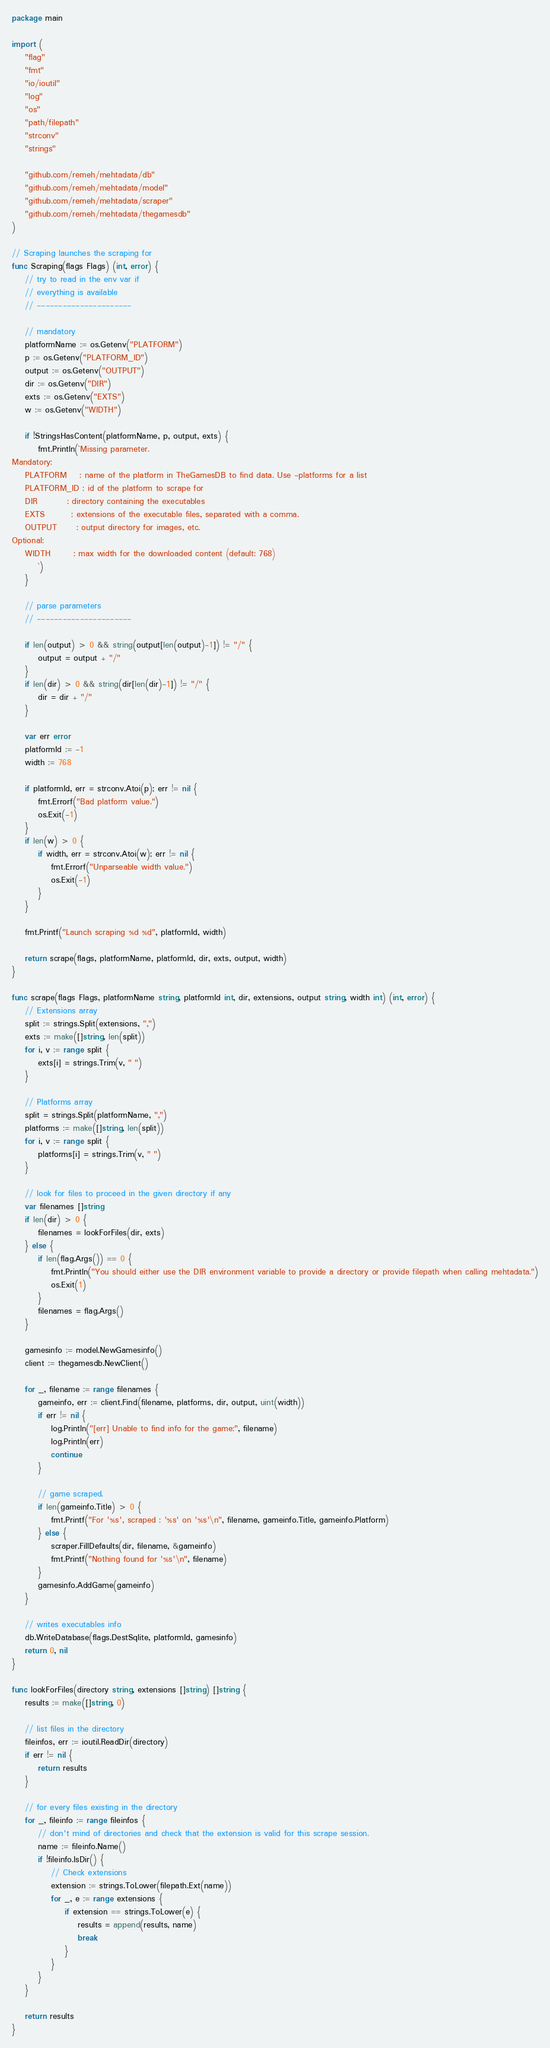Convert code to text. <code><loc_0><loc_0><loc_500><loc_500><_Go_>package main

import (
	"flag"
	"fmt"
	"io/ioutil"
	"log"
	"os"
	"path/filepath"
	"strconv"
	"strings"

	"github.com/remeh/mehtadata/db"
	"github.com/remeh/mehtadata/model"
	"github.com/remeh/mehtadata/scraper"
	"github.com/remeh/mehtadata/thegamesdb"
)

// Scraping launches the scraping for
func Scraping(flags Flags) (int, error) {
	// try to read in the env var if
	// everything is available
	// ----------------------

	// mandatory
	platformName := os.Getenv("PLATFORM")
	p := os.Getenv("PLATFORM_ID")
	output := os.Getenv("OUTPUT")
	dir := os.Getenv("DIR")
	exts := os.Getenv("EXTS")
	w := os.Getenv("WIDTH")

	if !StringsHasContent(platformName, p, output, exts) {
		fmt.Println(`Missing parameter.
Mandatory:
	PLATFORM    : name of the platform in TheGamesDB to find data. Use -platforms for a list
	PLATFORM_ID : id of the platform to scrape for
	DIR         : directory containing the executables
	EXTS        : extensions of the executable files, separated with a comma.
	OUTPUT      : output directory for images, etc.
Optional:
	WIDTH       : max width for the downloaded content (default: 768)
		`)
	}

	// parse parameters
	// ----------------------

	if len(output) > 0 && string(output[len(output)-1]) != "/" {
		output = output + "/"
	}
	if len(dir) > 0 && string(dir[len(dir)-1]) != "/" {
		dir = dir + "/"
	}

	var err error
	platformId := -1
	width := 768

	if platformId, err = strconv.Atoi(p); err != nil {
		fmt.Errorf("Bad platform value.")
		os.Exit(-1)
	}
	if len(w) > 0 {
		if width, err = strconv.Atoi(w); err != nil {
			fmt.Errorf("Unparseable width value.")
			os.Exit(-1)
		}
	}

	fmt.Printf("Launch scraping %d %d", platformId, width)

	return scrape(flags, platformName, platformId, dir, exts, output, width)
}

func scrape(flags Flags, platformName string, platformId int, dir, extensions, output string, width int) (int, error) {
	// Extensions array
	split := strings.Split(extensions, ",")
	exts := make([]string, len(split))
	for i, v := range split {
		exts[i] = strings.Trim(v, " ")
	}

	// Platforms array
	split = strings.Split(platformName, ",")
	platforms := make([]string, len(split))
	for i, v := range split {
		platforms[i] = strings.Trim(v, " ")
	}

	// look for files to proceed in the given directory if any
	var filenames []string
	if len(dir) > 0 {
		filenames = lookForFiles(dir, exts)
	} else {
		if len(flag.Args()) == 0 {
			fmt.Println("You should either use the DIR environment variable to provide a directory or provide filepath when calling mehtadata.")
			os.Exit(1)
		}
		filenames = flag.Args()
	}

	gamesinfo := model.NewGamesinfo()
	client := thegamesdb.NewClient()

	for _, filename := range filenames {
		gameinfo, err := client.Find(filename, platforms, dir, output, uint(width))
		if err != nil {
			log.Println("[err] Unable to find info for the game:", filename)
			log.Println(err)
			continue
		}

		// game scraped.
		if len(gameinfo.Title) > 0 {
			fmt.Printf("For '%s', scraped : '%s' on '%s'\n", filename, gameinfo.Title, gameinfo.Platform)
		} else {
			scraper.FillDefaults(dir, filename, &gameinfo)
			fmt.Printf("Nothing found for '%s'\n", filename)
		}
		gamesinfo.AddGame(gameinfo)
	}

	// writes executables info
	db.WriteDatabase(flags.DestSqlite, platformId, gamesinfo)
	return 0, nil
}

func lookForFiles(directory string, extensions []string) []string {
	results := make([]string, 0)

	// list files in the directory
	fileinfos, err := ioutil.ReadDir(directory)
	if err != nil {
		return results
	}

	// for every files existing in the directory
	for _, fileinfo := range fileinfos {
		// don't mind of directories and check that the extension is valid for this scrape session.
		name := fileinfo.Name()
		if !fileinfo.IsDir() {
			// Check extensions
			extension := strings.ToLower(filepath.Ext(name))
			for _, e := range extensions {
				if extension == strings.ToLower(e) {
					results = append(results, name)
					break
				}
			}
		}
	}

	return results
}
</code> 